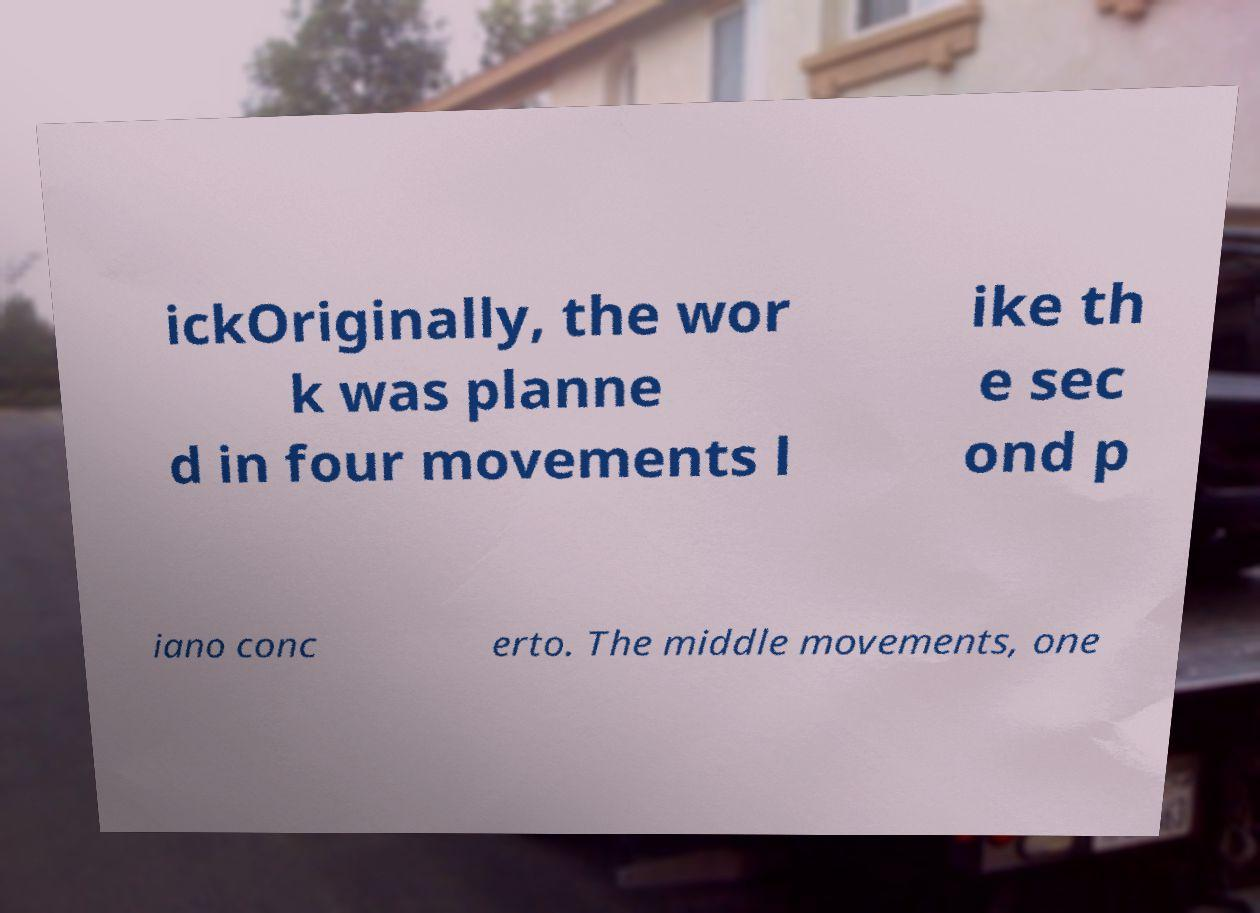There's text embedded in this image that I need extracted. Can you transcribe it verbatim? ickOriginally, the wor k was planne d in four movements l ike th e sec ond p iano conc erto. The middle movements, one 